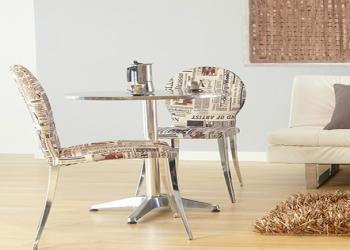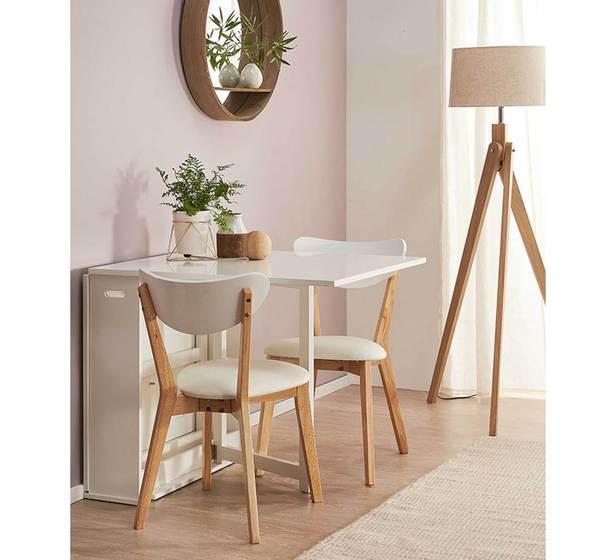The first image is the image on the left, the second image is the image on the right. Examine the images to the left and right. Is the description "The right image shows a small table white table with two chairs that sits flush to a wall and has a top that extends outward." accurate? Answer yes or no. Yes. The first image is the image on the left, the second image is the image on the right. Assess this claim about the two images: "One of the images shows a high top table with stools.". Correct or not? Answer yes or no. No. 